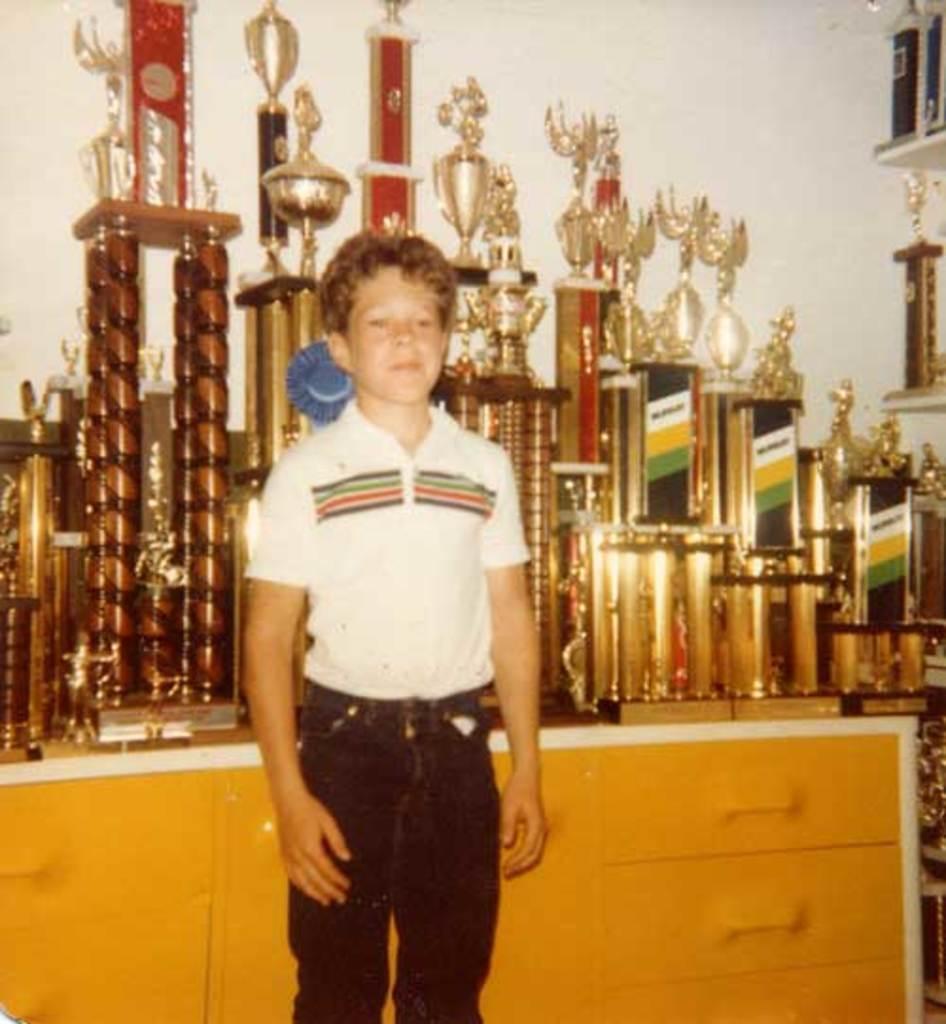Describe this image in one or two sentences. In this image I can see a boy is standing. I can see he is wearing white t shirt and black jeans. In the background I can see number of trophies and drawers. 